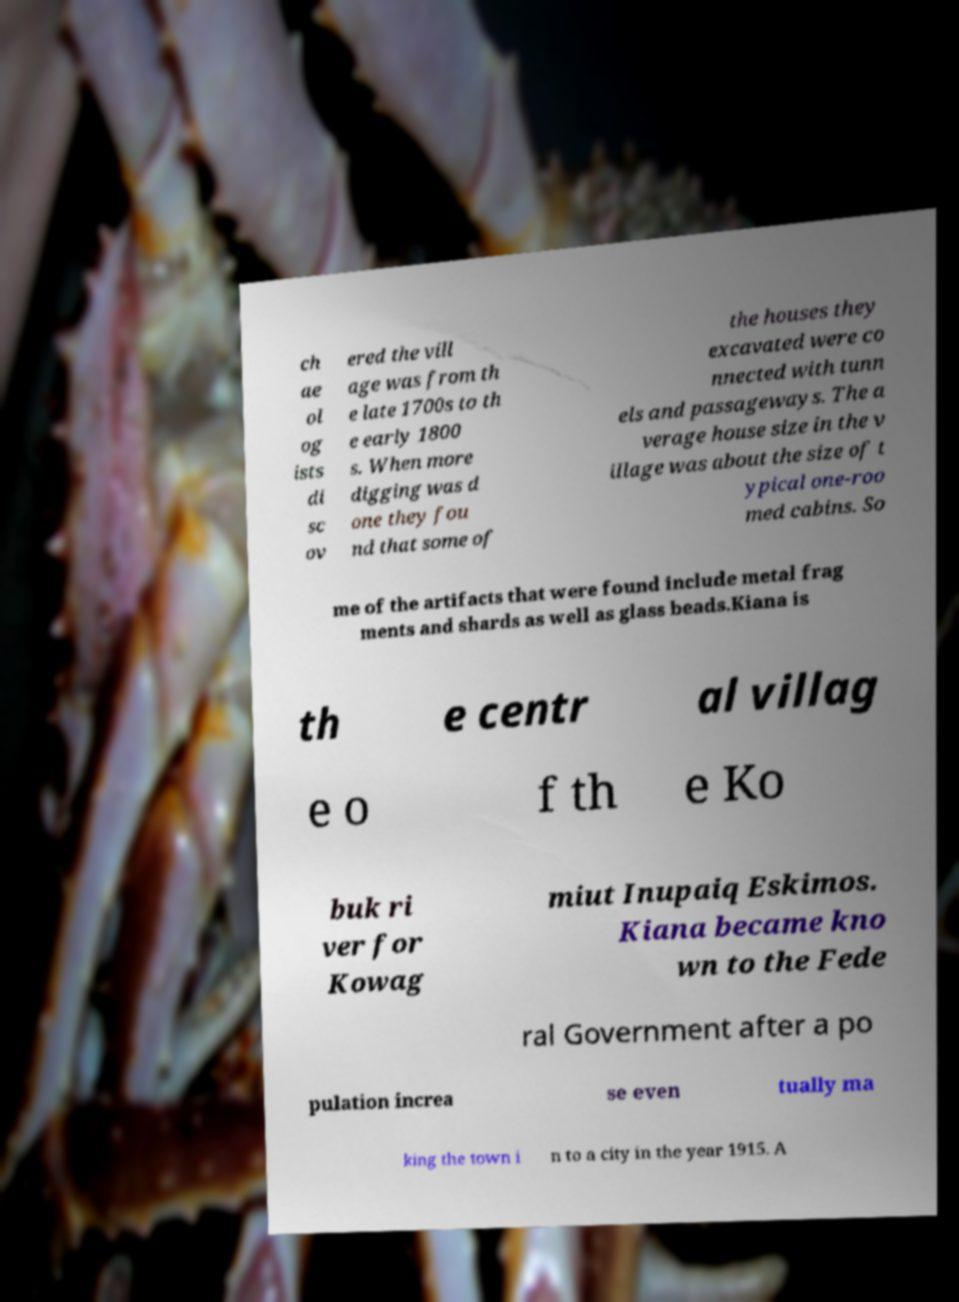I need the written content from this picture converted into text. Can you do that? ch ae ol og ists di sc ov ered the vill age was from th e late 1700s to th e early 1800 s. When more digging was d one they fou nd that some of the houses they excavated were co nnected with tunn els and passageways. The a verage house size in the v illage was about the size of t ypical one-roo med cabins. So me of the artifacts that were found include metal frag ments and shards as well as glass beads.Kiana is th e centr al villag e o f th e Ko buk ri ver for Kowag miut Inupaiq Eskimos. Kiana became kno wn to the Fede ral Government after a po pulation increa se even tually ma king the town i n to a city in the year 1915. A 